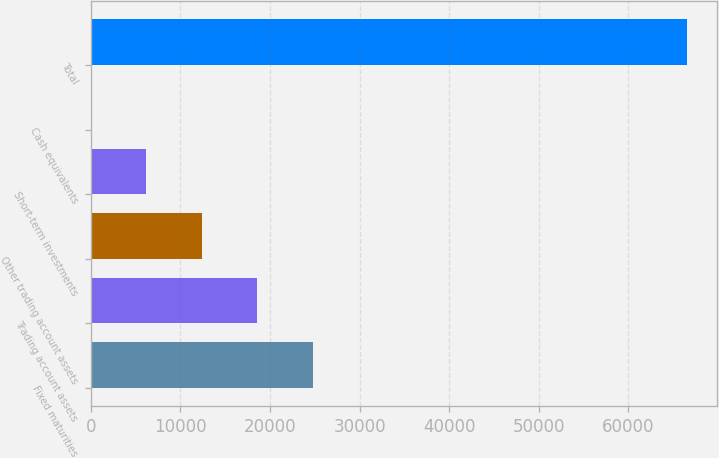<chart> <loc_0><loc_0><loc_500><loc_500><bar_chart><fcel>Fixed maturities<fcel>Trading account assets<fcel>Other trading account assets<fcel>Short-term investments<fcel>Cash equivalents<fcel>Total<nl><fcel>24747.7<fcel>18561.3<fcel>12374.9<fcel>6188.54<fcel>2.16<fcel>66565.4<nl></chart> 